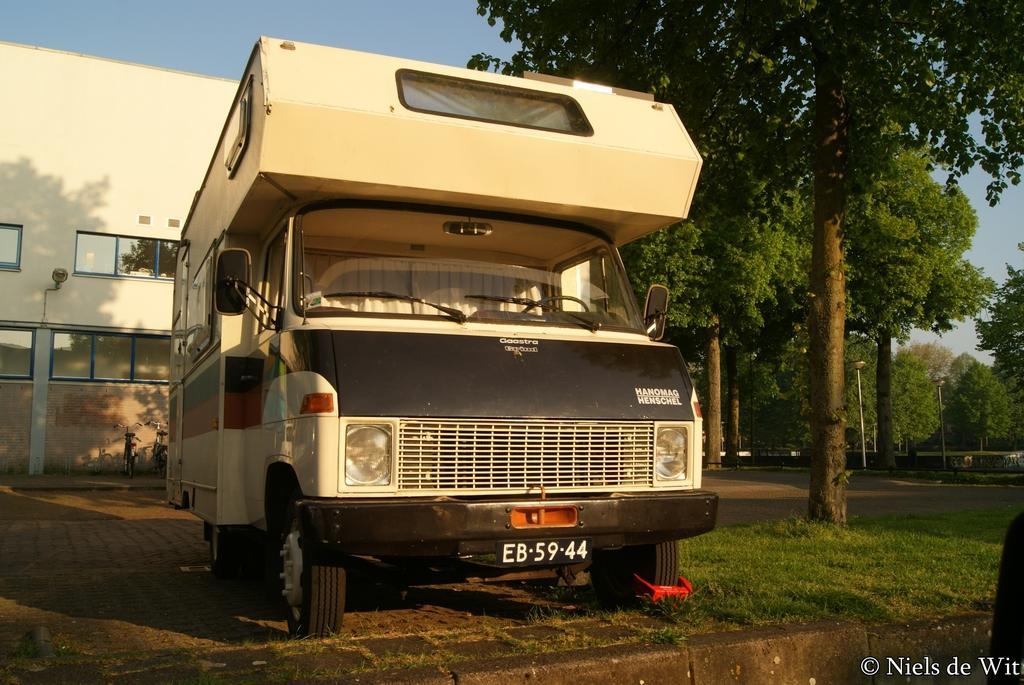Describe this image in one or two sentences. In this image we can see a vehicle with a number plate. On the ground there is grass. Also there are trees. In the back there is a building with windows. In the background there is sky. In the right bottom corner there is a text. 